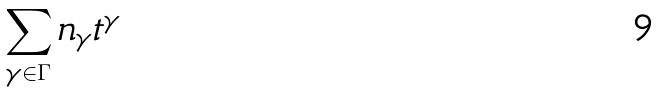Convert formula to latex. <formula><loc_0><loc_0><loc_500><loc_500>\sum _ { \gamma \in \Gamma } n _ { \gamma } t ^ { \gamma }</formula> 